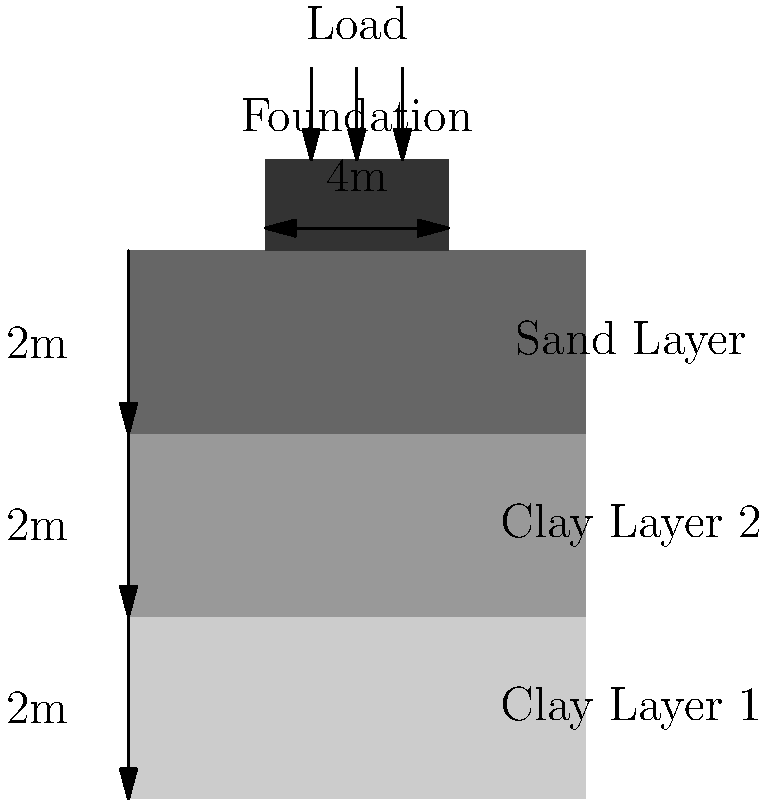As a young and innovative producer working on remastering albums, you've been tasked with estimating the settlement of a recording studio's foundation. The studio is built on a layered soil profile as shown in the diagram. The foundation is 4m wide and applies a total load of 500 kN/m. Given the soil properties below, estimate the total settlement of the foundation:

Clay Layer 1: $E_s = 20$ MPa, $\nu = 0.35$, thickness = 2m
Clay Layer 2: $E_s = 30$ MPa, $\nu = 0.35$, thickness = 2m
Sand Layer: $E_s = 50$ MPa, $\nu = 0.30$, thickness = 2m

Use the elastic settlement equation: $S = q B \frac{(1-\nu^2)}{E_s} I_s$, where $I_s = 1$ for this case, and $q$ is the applied pressure. To estimate the total settlement, we need to calculate the settlement for each layer and sum them up. Let's go through this step-by-step:

1. Calculate the applied pressure:
   $q = \frac{\text{Total load}}{\text{Foundation width}} = \frac{500 \text{ kN/m}}{4 \text{ m}} = 125 \text{ kN/m}^2 = 125 \text{ kPa}$

2. For each layer, use the elastic settlement equation:
   $S = q B \frac{(1-\nu^2)}{E_s} I_s$, where $B = 4\text{ m}$ and $I_s = 1$

3. Clay Layer 1:
   $S_1 = 125 \cdot 4 \cdot \frac{(1-0.35^2)}{20 \cdot 10^6} \cdot 1 = 0.0214 \text{ m}$

4. Clay Layer 2:
   $S_2 = 125 \cdot 4 \cdot \frac{(1-0.35^2)}{30 \cdot 10^6} \cdot 1 = 0.0143 \text{ m}$

5. Sand Layer:
   $S_3 = 125 \cdot 4 \cdot \frac{(1-0.30^2)}{50 \cdot 10^6} \cdot 1 = 0.0086 \text{ m}$

6. Sum up the settlements:
   $S_{\text{total}} = S_1 + S_2 + S_3 = 0.0214 + 0.0143 + 0.0086 = 0.0443 \text{ m} = 44.3 \text{ mm}$

Therefore, the total estimated settlement of the foundation is 44.3 mm.
Answer: 44.3 mm 